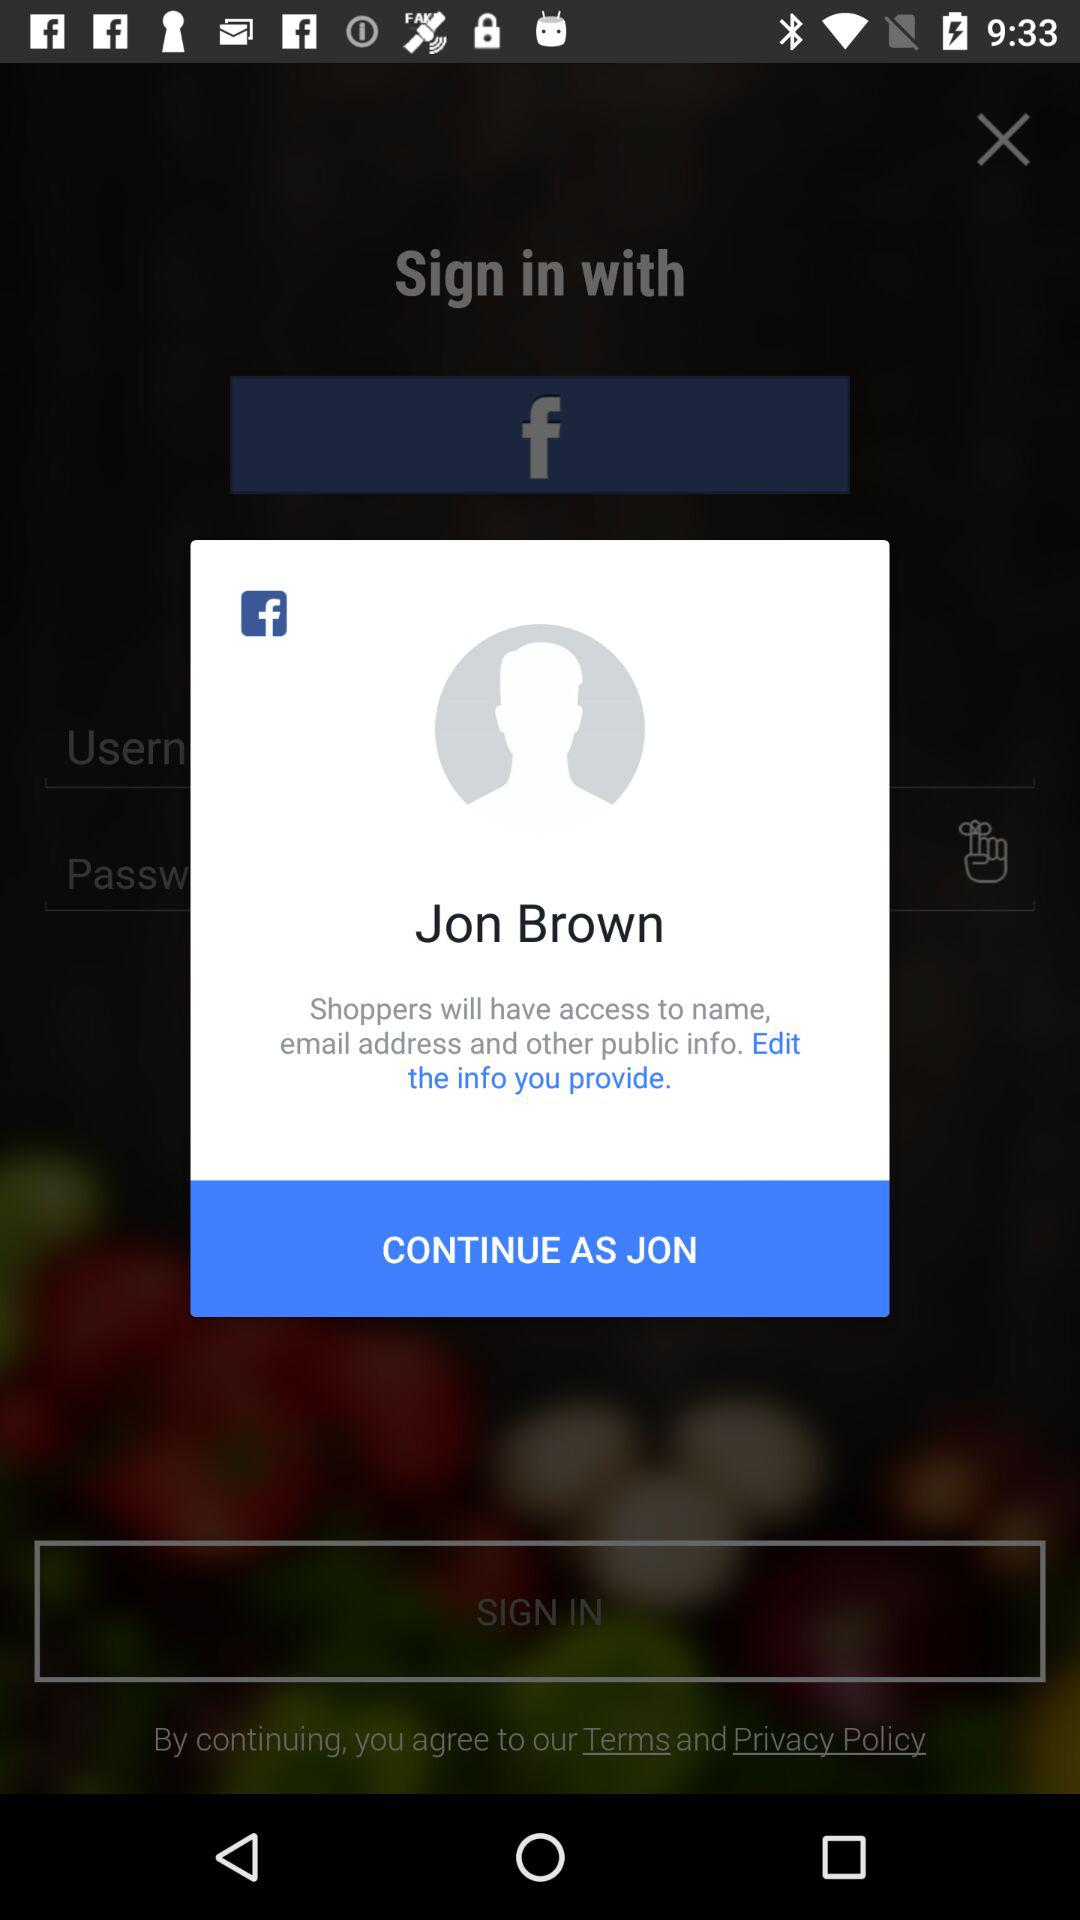What is the name of the user? The name of the user is Jon Brown. 